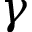Convert formula to latex. <formula><loc_0><loc_0><loc_500><loc_500>\gamma</formula> 